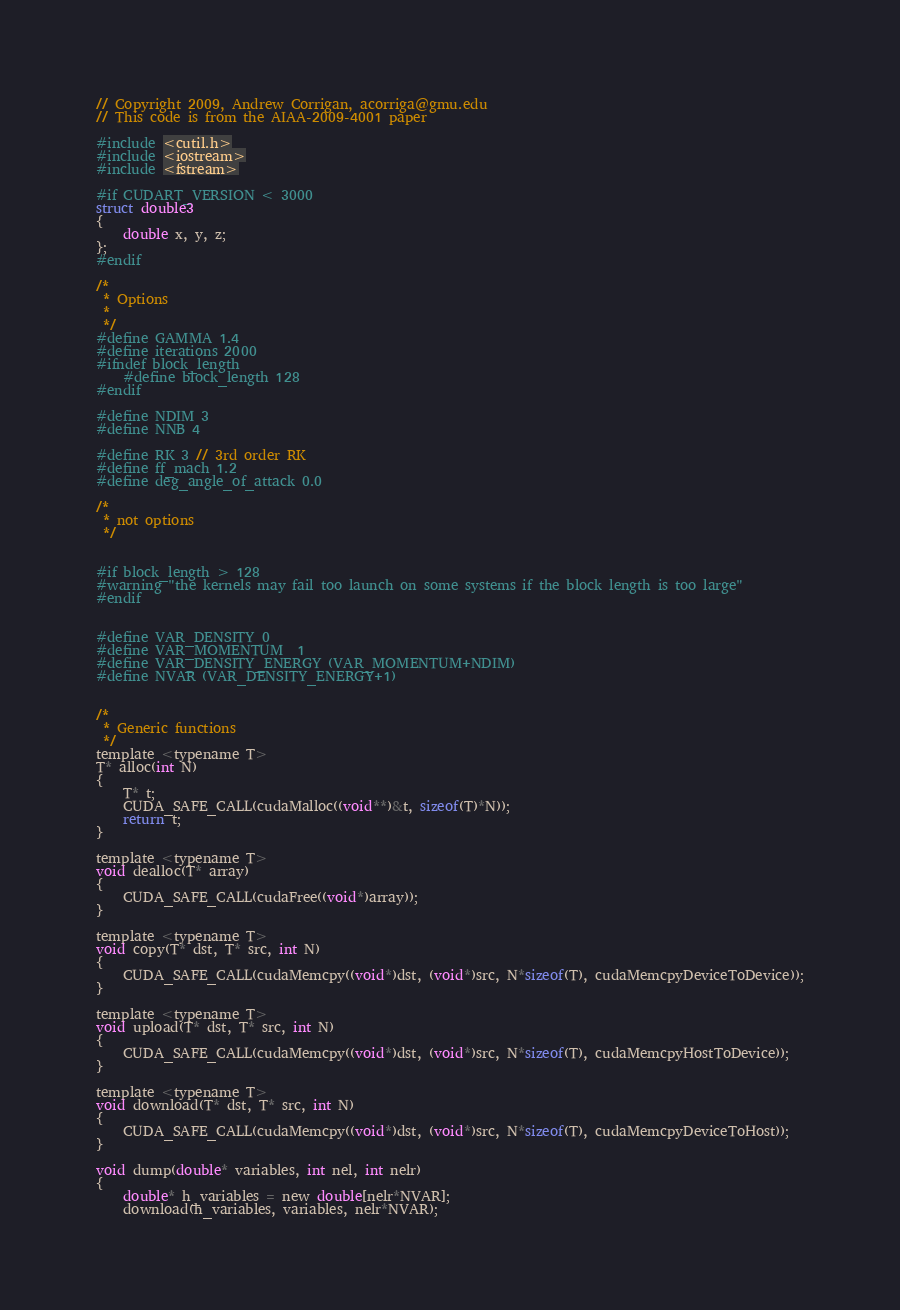<code> <loc_0><loc_0><loc_500><loc_500><_Cuda_>// Copyright 2009, Andrew Corrigan, acorriga@gmu.edu
// This code is from the AIAA-2009-4001 paper

#include <cutil.h>
#include <iostream>
#include <fstream>

#if CUDART_VERSION < 3000
struct double3
{
	double x, y, z;
};
#endif

/*
 * Options 
 * 
 */ 
#define GAMMA 1.4
#define iterations 2000
#ifndef block_length
	#define block_length 128
#endif

#define NDIM 3
#define NNB 4

#define RK 3	// 3rd order RK
#define ff_mach 1.2
#define deg_angle_of_attack 0.0

/*
 * not options
 */


#if block_length > 128
#warning "the kernels may fail too launch on some systems if the block length is too large"
#endif


#define VAR_DENSITY 0
#define VAR_MOMENTUM  1
#define VAR_DENSITY_ENERGY (VAR_MOMENTUM+NDIM)
#define NVAR (VAR_DENSITY_ENERGY+1)


/*
 * Generic functions
 */
template <typename T>
T* alloc(int N)
{
	T* t;
	CUDA_SAFE_CALL(cudaMalloc((void**)&t, sizeof(T)*N));
	return t;
}

template <typename T>
void dealloc(T* array)
{
	CUDA_SAFE_CALL(cudaFree((void*)array));
}

template <typename T>
void copy(T* dst, T* src, int N)
{
	CUDA_SAFE_CALL(cudaMemcpy((void*)dst, (void*)src, N*sizeof(T), cudaMemcpyDeviceToDevice));
}

template <typename T>
void upload(T* dst, T* src, int N)
{
	CUDA_SAFE_CALL(cudaMemcpy((void*)dst, (void*)src, N*sizeof(T), cudaMemcpyHostToDevice));
}

template <typename T>
void download(T* dst, T* src, int N)
{
	CUDA_SAFE_CALL(cudaMemcpy((void*)dst, (void*)src, N*sizeof(T), cudaMemcpyDeviceToHost));
}

void dump(double* variables, int nel, int nelr)
{
	double* h_variables = new double[nelr*NVAR];
	download(h_variables, variables, nelr*NVAR);
</code> 